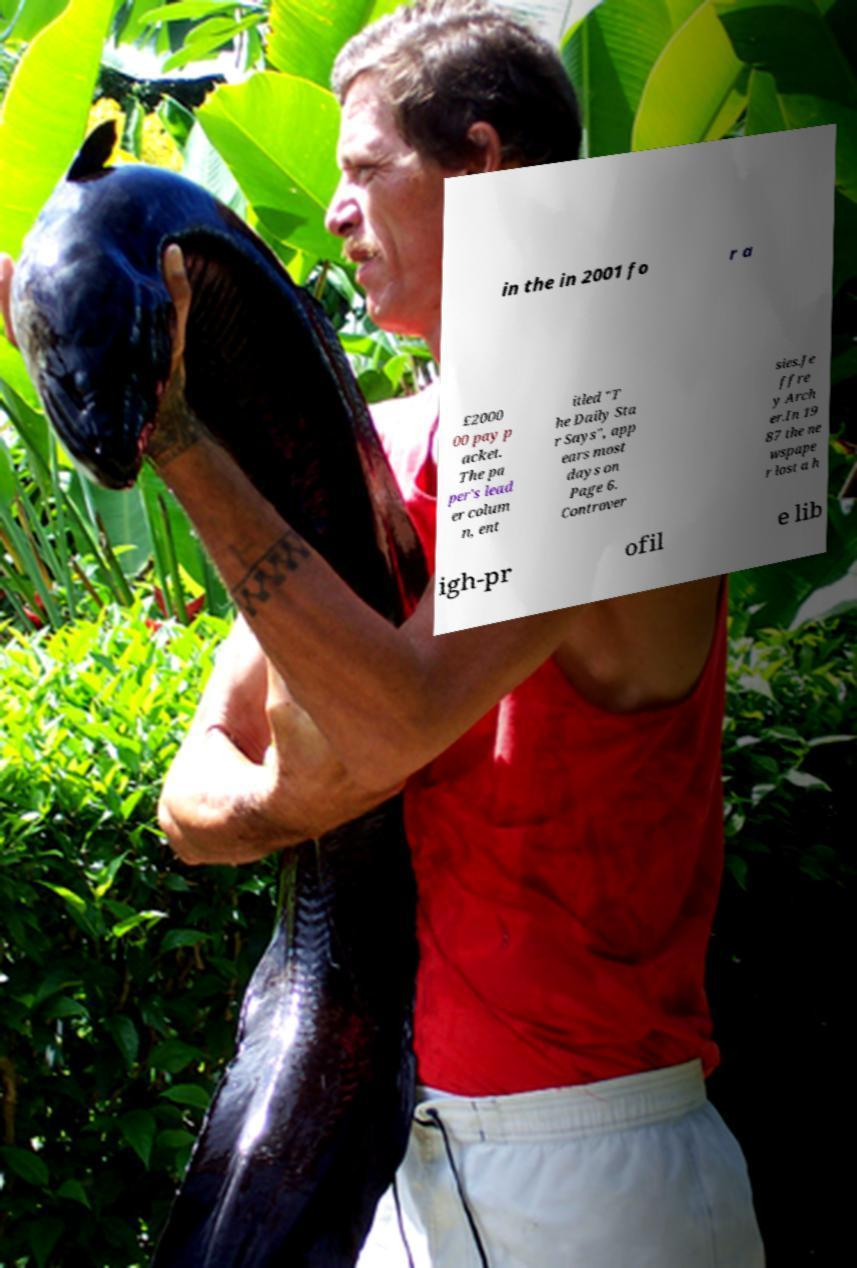Can you accurately transcribe the text from the provided image for me? in the in 2001 fo r a £2000 00 pay p acket. The pa per's lead er colum n, ent itled "T he Daily Sta r Says", app ears most days on Page 6. Controver sies.Je ffre y Arch er.In 19 87 the ne wspape r lost a h igh-pr ofil e lib 